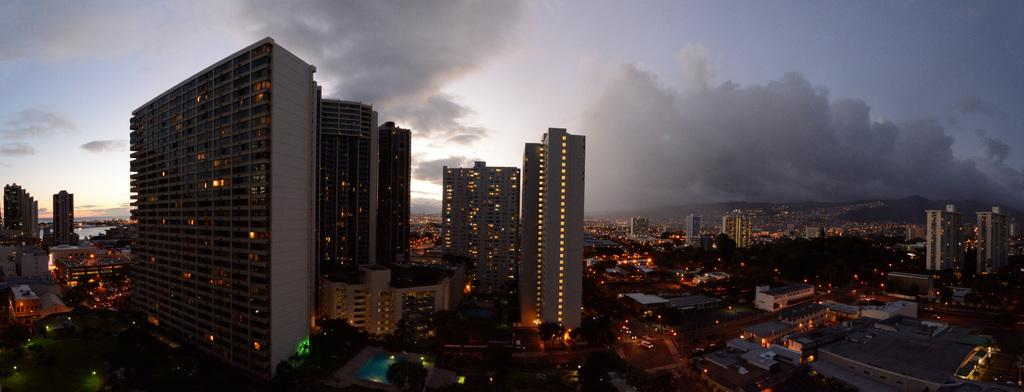What type of structures can be seen in the image? There are buildings in the image. What can be seen illuminating the scene in the image? There are lights visible in the image. What type of natural vegetation is present in the image? There are trees in the image. What type of man-made objects are present in the image? There are vehicles in the image. What other objects can be seen in the image? There are other objects in the image. How would you describe the weather in the image? The sky is cloudy in the image. What type of winter activity is taking place in the image? There is no winter activity present in the image. Can you see a pail being used for any purpose in the image? There is no pail present in the image. 